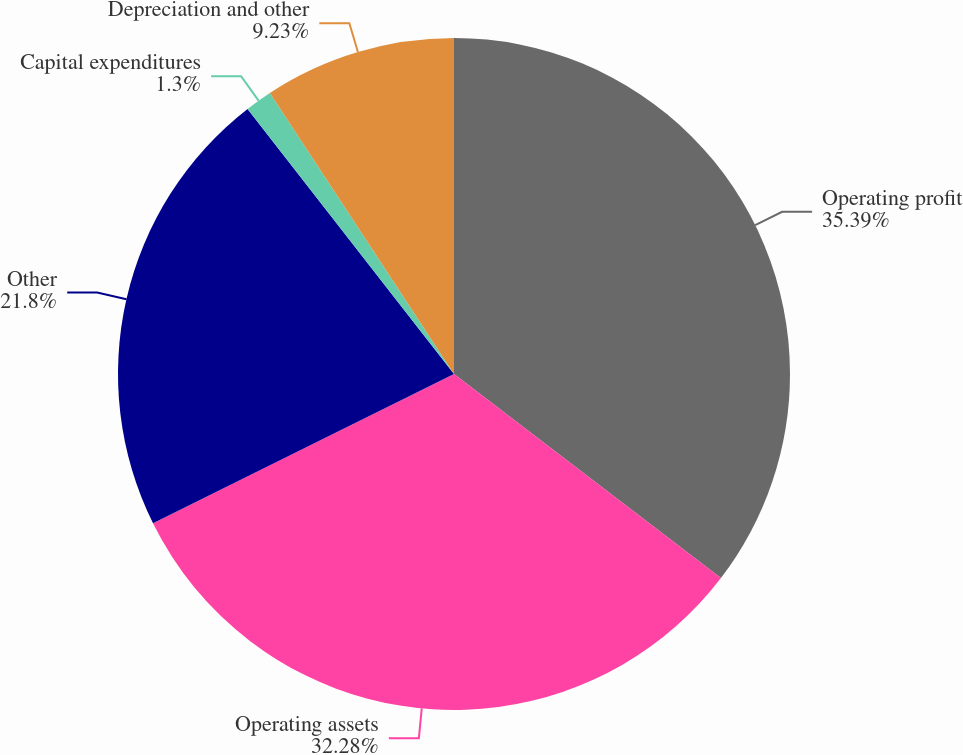Convert chart. <chart><loc_0><loc_0><loc_500><loc_500><pie_chart><fcel>Operating profit<fcel>Operating assets<fcel>Other<fcel>Capital expenditures<fcel>Depreciation and other<nl><fcel>35.39%<fcel>32.28%<fcel>21.8%<fcel>1.3%<fcel>9.23%<nl></chart> 